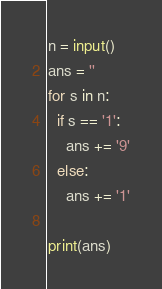Convert code to text. <code><loc_0><loc_0><loc_500><loc_500><_Python_>n = input()
ans = ''
for s in n:
  if s == '1':
    ans += '9'
  else:
    ans += '1'

print(ans)</code> 